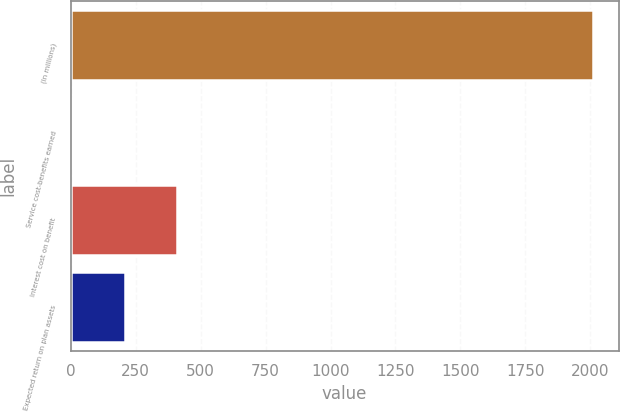Convert chart. <chart><loc_0><loc_0><loc_500><loc_500><bar_chart><fcel>(In millions)<fcel>Service cost-benefits earned<fcel>Interest cost on benefit<fcel>Expected return on plan assets<nl><fcel>2008<fcel>10.9<fcel>410.32<fcel>210.61<nl></chart> 